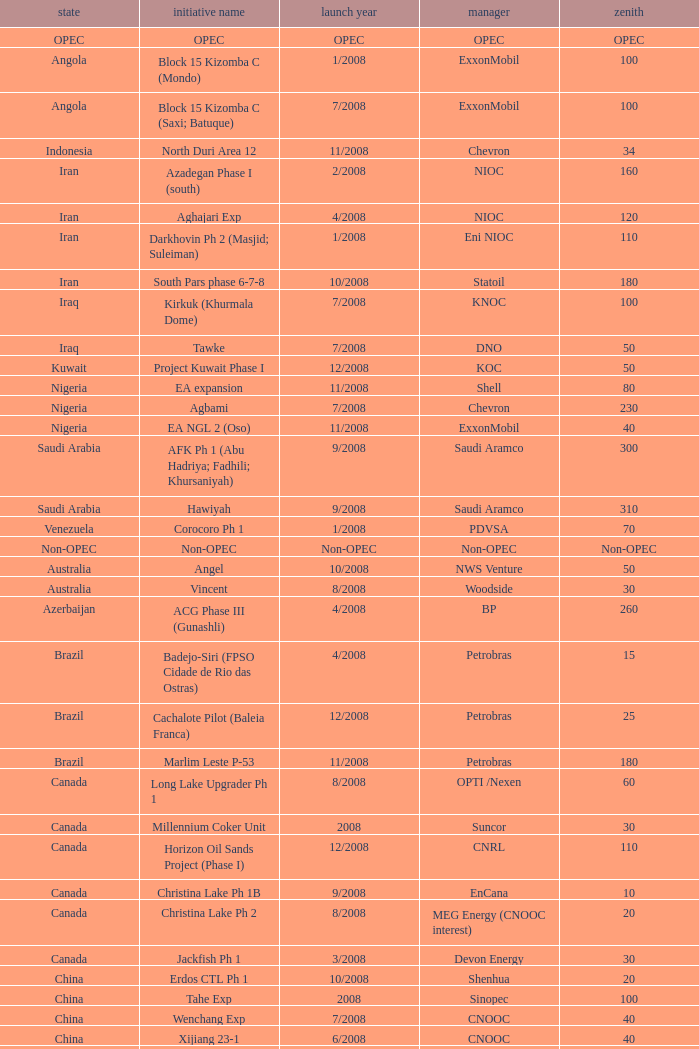What is the peak associated with the project named talakan ph 1? 60.0. 